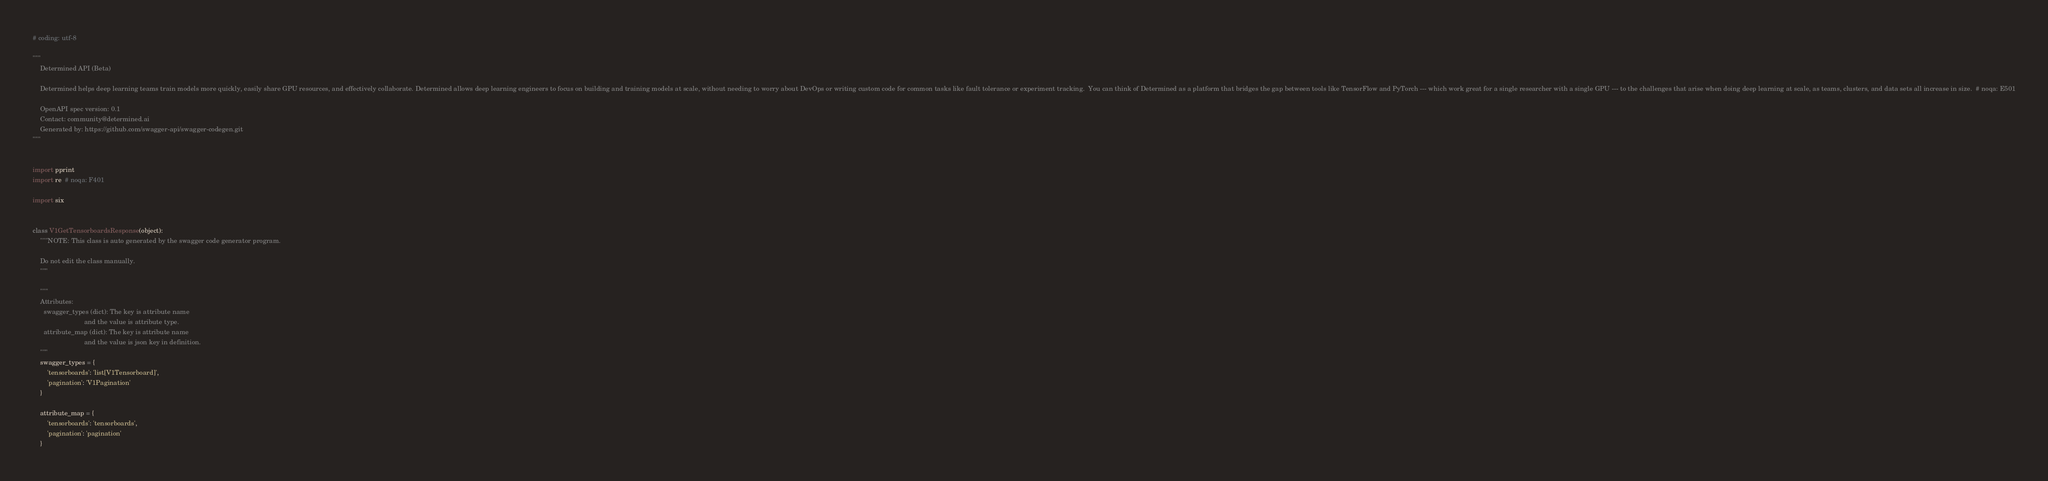Convert code to text. <code><loc_0><loc_0><loc_500><loc_500><_Python_># coding: utf-8

"""
    Determined API (Beta)

    Determined helps deep learning teams train models more quickly, easily share GPU resources, and effectively collaborate. Determined allows deep learning engineers to focus on building and training models at scale, without needing to worry about DevOps or writing custom code for common tasks like fault tolerance or experiment tracking.  You can think of Determined as a platform that bridges the gap between tools like TensorFlow and PyTorch --- which work great for a single researcher with a single GPU --- to the challenges that arise when doing deep learning at scale, as teams, clusters, and data sets all increase in size.  # noqa: E501

    OpenAPI spec version: 0.1
    Contact: community@determined.ai
    Generated by: https://github.com/swagger-api/swagger-codegen.git
"""


import pprint
import re  # noqa: F401

import six


class V1GetTensorboardsResponse(object):
    """NOTE: This class is auto generated by the swagger code generator program.

    Do not edit the class manually.
    """

    """
    Attributes:
      swagger_types (dict): The key is attribute name
                            and the value is attribute type.
      attribute_map (dict): The key is attribute name
                            and the value is json key in definition.
    """
    swagger_types = {
        'tensorboards': 'list[V1Tensorboard]',
        'pagination': 'V1Pagination'
    }

    attribute_map = {
        'tensorboards': 'tensorboards',
        'pagination': 'pagination'
    }
</code> 